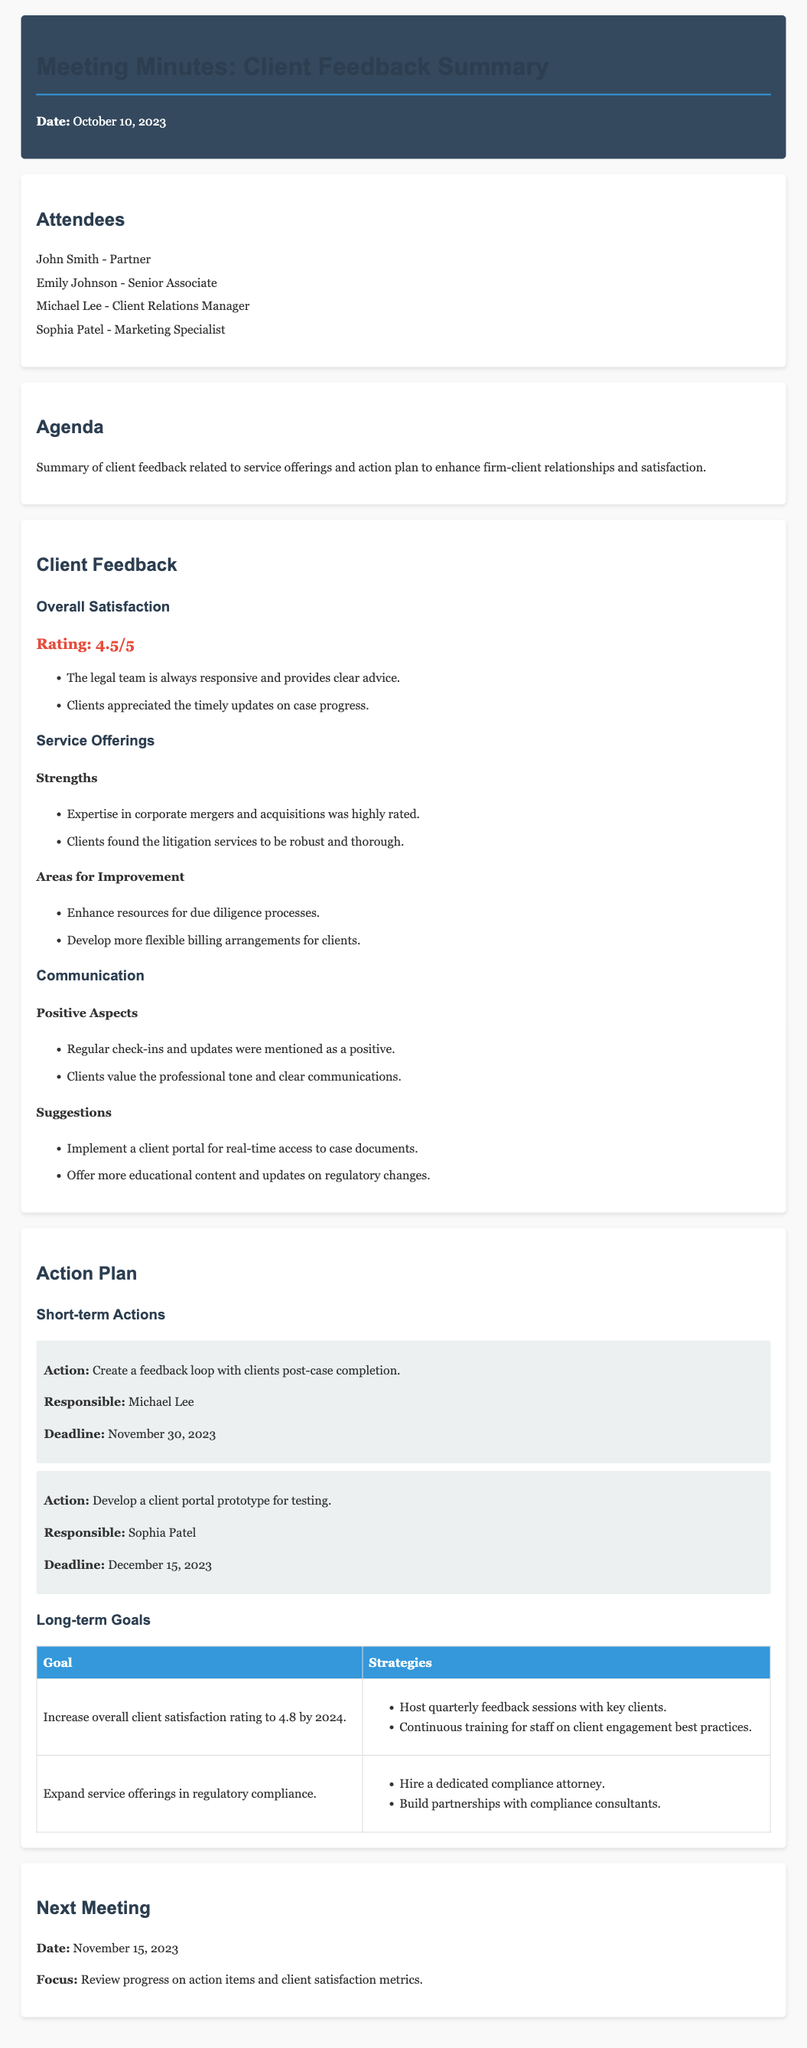What was the overall satisfaction rating? The overall satisfaction rating is highlighted in the document as a key metric of client feedback.
Answer: 4.5/5 Who is responsible for creating a feedback loop with clients post-case completion? This information is found under the short-term actions section, detailing who is accountable for specific tasks.
Answer: Michael Lee When is the next meeting scheduled? The next meeting date is mentioned in the final section of the document, focusing on future commitments.
Answer: November 15, 2023 What is one area for improvement in service offerings? This question seeks to highlight specific areas identified for enhancement based on client feedback regarding services.
Answer: Enhance resources for due diligence processes What is the goal regarding client satisfaction by 2024? The document includes measurable goals set for enhancing client satisfaction, indicating a target for improvement.
Answer: 4.8 What is one strategy to increase client satisfaction? The document outlines specific strategies aimed at achieving the set goals, showcasing actionable steps taken by the firm.
Answer: Host quarterly feedback sessions with key clients What is included in the positive aspects of communication? This question focuses on the feedback about communication and highlights what clients appreciated regarding the firm's communication practices.
Answer: Regular check-ins and updates Who is responsible for developing a client portal prototype? The document contains assignments for various actions, providing clarity on responsibilities among team members.
Answer: Sophia Patel 